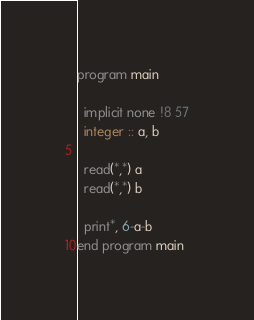<code> <loc_0><loc_0><loc_500><loc_500><_FORTRAN_>program main
  
  implicit none !8 57
  integer :: a, b

  read(*,*) a
  read(*,*) b
  
  print*, 6-a-b
end program main
</code> 